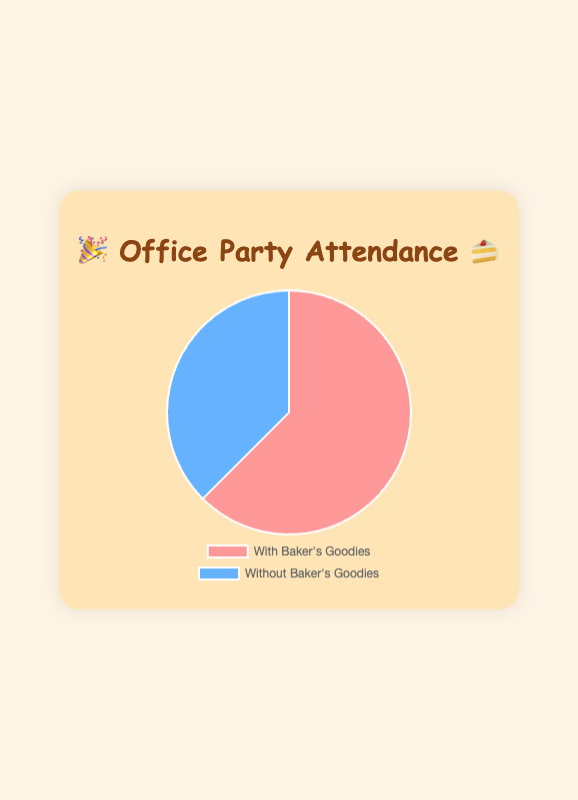What's the attendance percentage at office parties with the baker's involvement? The slice labelled 'With Baker's Goodies' shows an attendance of 75%. This can be directly read from the pie chart.
Answer: 75% What's the difference in attendance percentages between office parties with and without the baker's involvement? The attendance percentage for office parties with the baker's involvement is 75%, and without is 45%. The difference is calculated as 75% - 45%.
Answer: 30% Which slice of the pie chart has a larger section, the one with or without the baker's involvement? The slice representing 'With Baker's Goodies' appears larger than the one representing 'Without Baker's Goodies'.
Answer: With Baker's Goodies What percentage of attendees do not attend office parties without the baker's involvement? The total attendance without the baker's involvement is 45%, so the percentage of attendees who do not attend is calculated as 100% - 45%.
Answer: 55% How much larger is the attendance at office parties with the baker's involvement compared to without the baker's involvement? Attendance with the baker's involvement is 75%. Attendance without is 45%. The increase can be calculated as 75% - 45%.
Answer: 30% Which group has less than 50% attendance in the chart? The 'Without Baker's Goodies' group has an attendance of 45%, which is less than 50%.
Answer: Without Baker's Goodies What is the visual difference in terms of background colors between the two groups in the pie chart? The 'With Baker's Goodies' slice is colored pink, while the 'Without Baker's Goodies' slice is colored blue.
Answer: Pink and Blue Calculate the total number of attendees mentioned in both categories combined. The total number of attendees is found by summing up the attendees from both categories: 75 (with baker) + 45 (without baker) = 120.
Answer: 120 